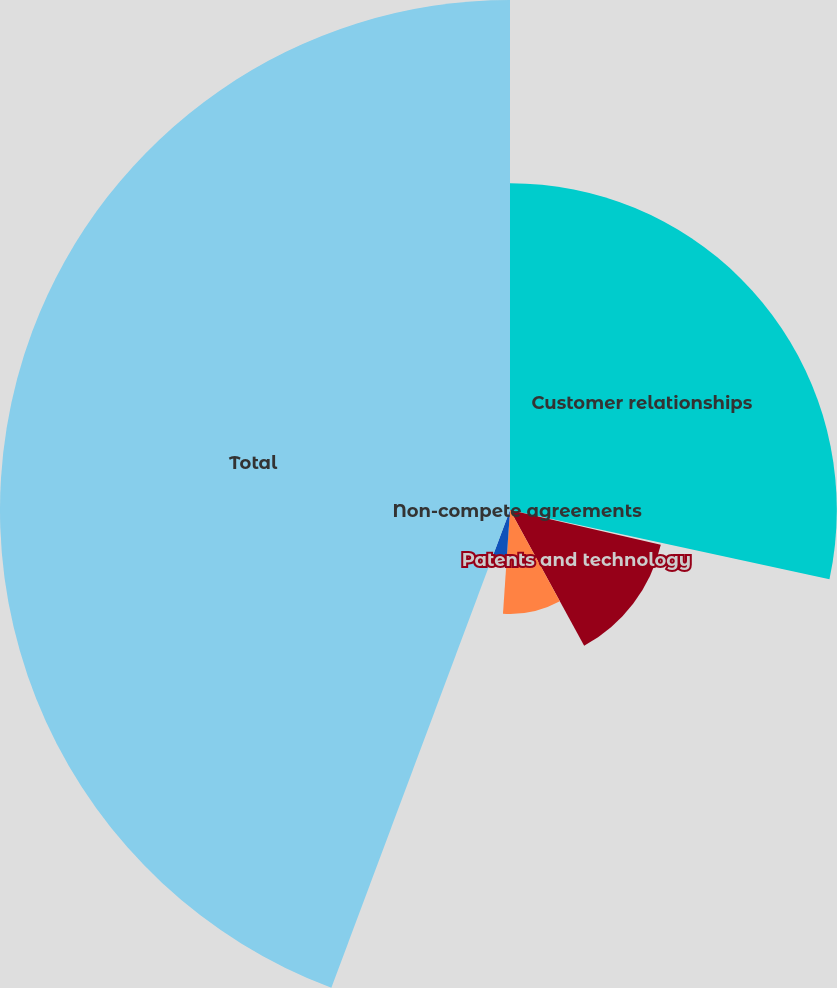Convert chart. <chart><loc_0><loc_0><loc_500><loc_500><pie_chart><fcel>Customer relationships<fcel>Non-compete agreements<fcel>Patents and technology<fcel>Trademarks and tradenames<fcel>Supplier relationships<fcel>Total<nl><fcel>28.39%<fcel>0.21%<fcel>13.44%<fcel>9.03%<fcel>4.62%<fcel>44.3%<nl></chart> 